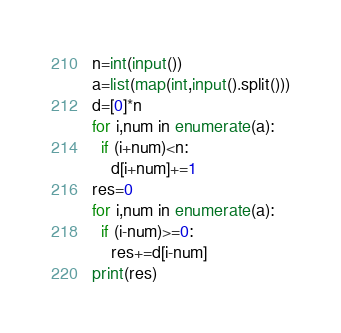Convert code to text. <code><loc_0><loc_0><loc_500><loc_500><_Python_>n=int(input())
a=list(map(int,input().split()))
d=[0]*n
for i,num in enumerate(a):
  if (i+num)<n:
    d[i+num]+=1
res=0
for i,num in enumerate(a):
  if (i-num)>=0:
    res+=d[i-num]
print(res)</code> 